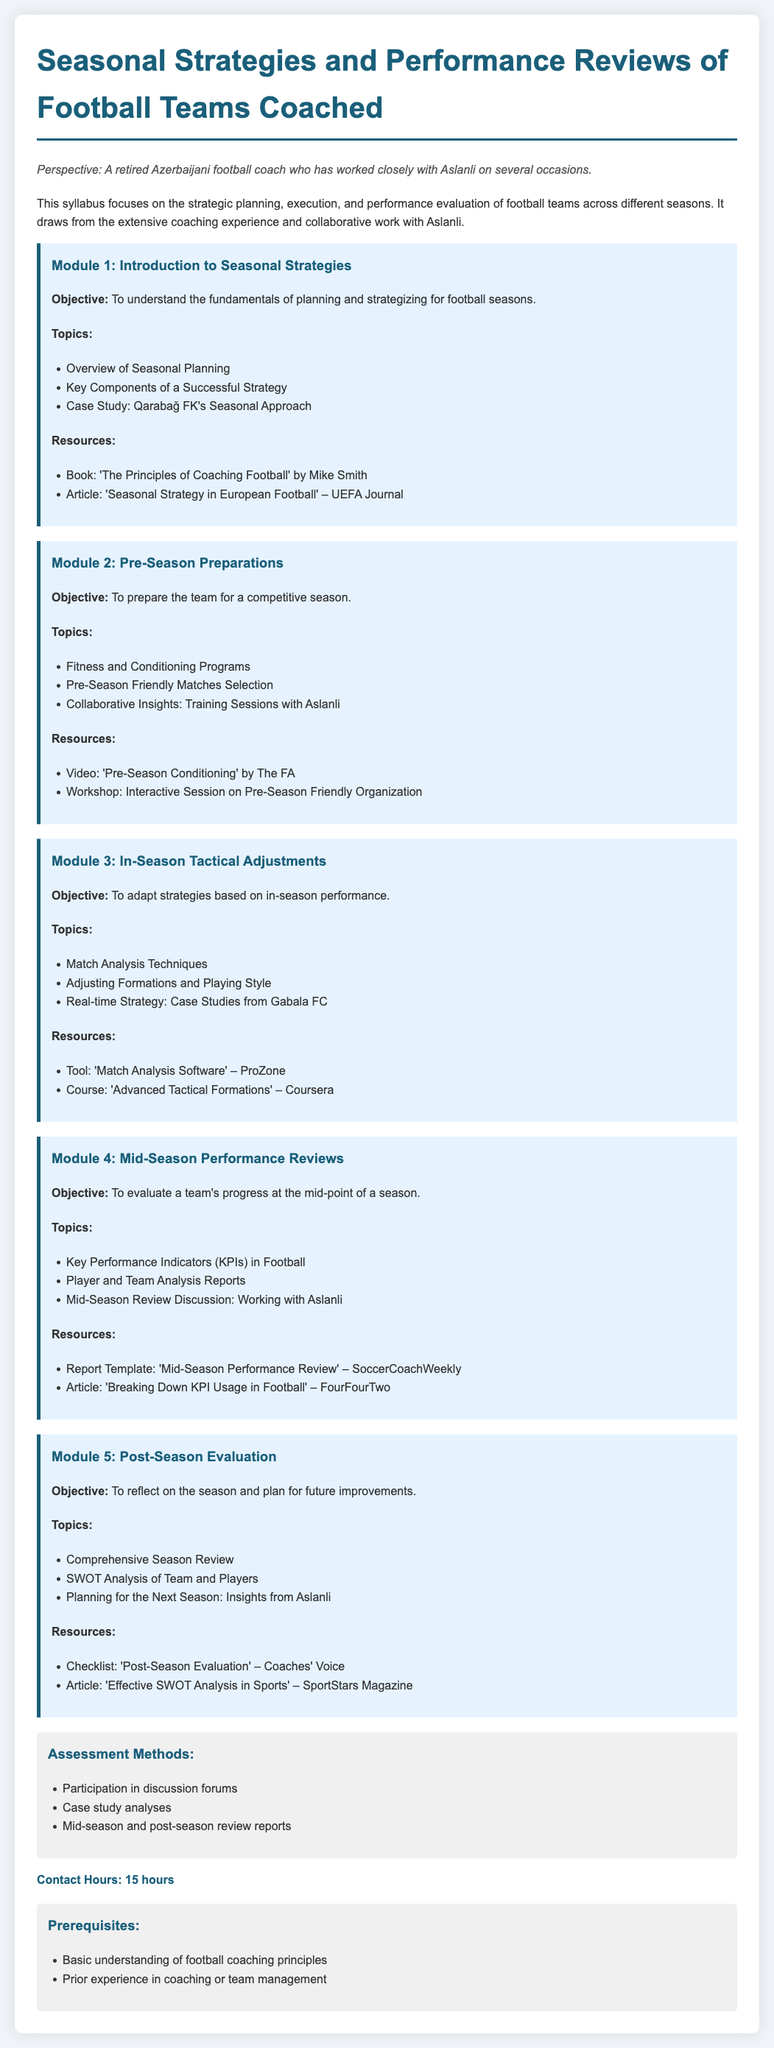What is the title of the syllabus? The title of the syllabus is provided in the document's header as "Seasonal Strategies and Performance Reviews of Football Teams Coached."
Answer: Seasonal Strategies and Performance Reviews of Football Teams Coached How many modules are there in the syllabus? The syllabus lists five modules that cover various topics related to seasonal strategies and performance reviews.
Answer: 5 What is the objective of Module 4? The objective of Module 4 is to evaluate a team's progress at the mid-point of a season, focusing on performance reviews.
Answer: To evaluate a team's progress at the mid-point of a season Who authored the suggested book resource for Module 1? The suggested book resource for Module 1, titled 'The Principles of Coaching Football,' is authored by Mike Smith.
Answer: Mike Smith What kind of analysis is included in the Post-Season Evaluation module? The Post-Season Evaluation module includes a SWOT analysis of the team and players.
Answer: SWOT Analysis What type of assessment is mentioned in the assessment methods? One of the assessment methods mentioned is participation in discussion forums.
Answer: Participation in discussion forums 